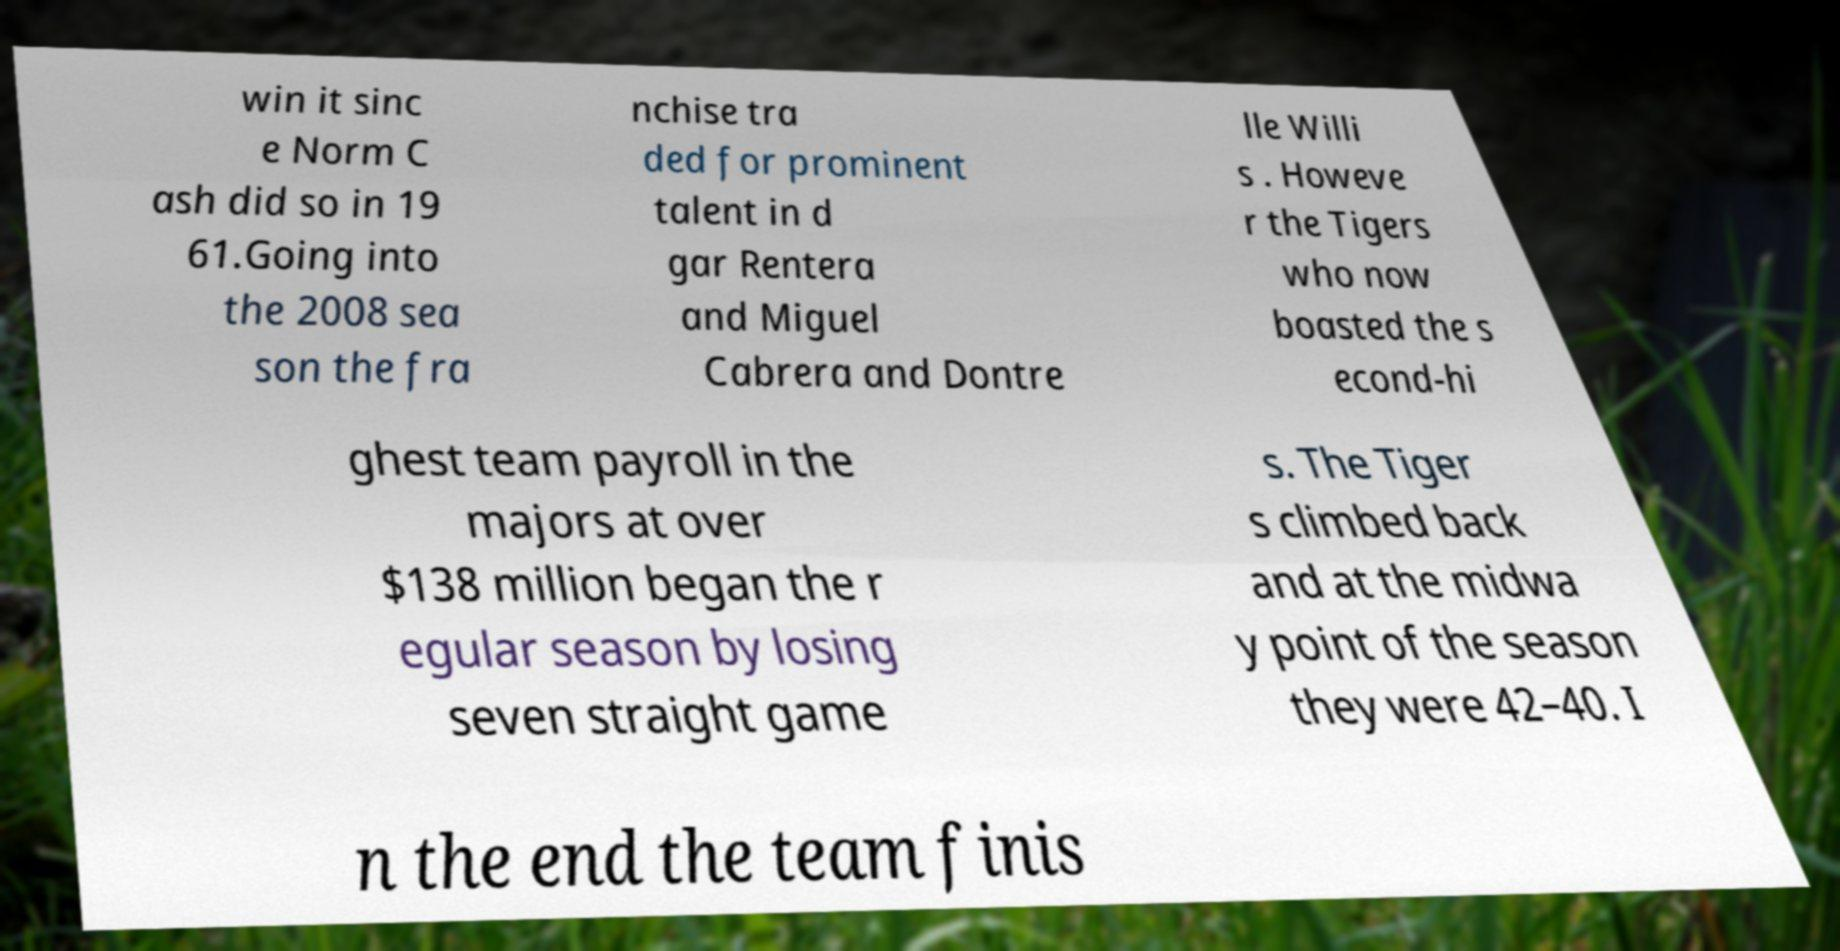Please identify and transcribe the text found in this image. win it sinc e Norm C ash did so in 19 61.Going into the 2008 sea son the fra nchise tra ded for prominent talent in d gar Rentera and Miguel Cabrera and Dontre lle Willi s . Howeve r the Tigers who now boasted the s econd-hi ghest team payroll in the majors at over $138 million began the r egular season by losing seven straight game s. The Tiger s climbed back and at the midwa y point of the season they were 42–40. I n the end the team finis 